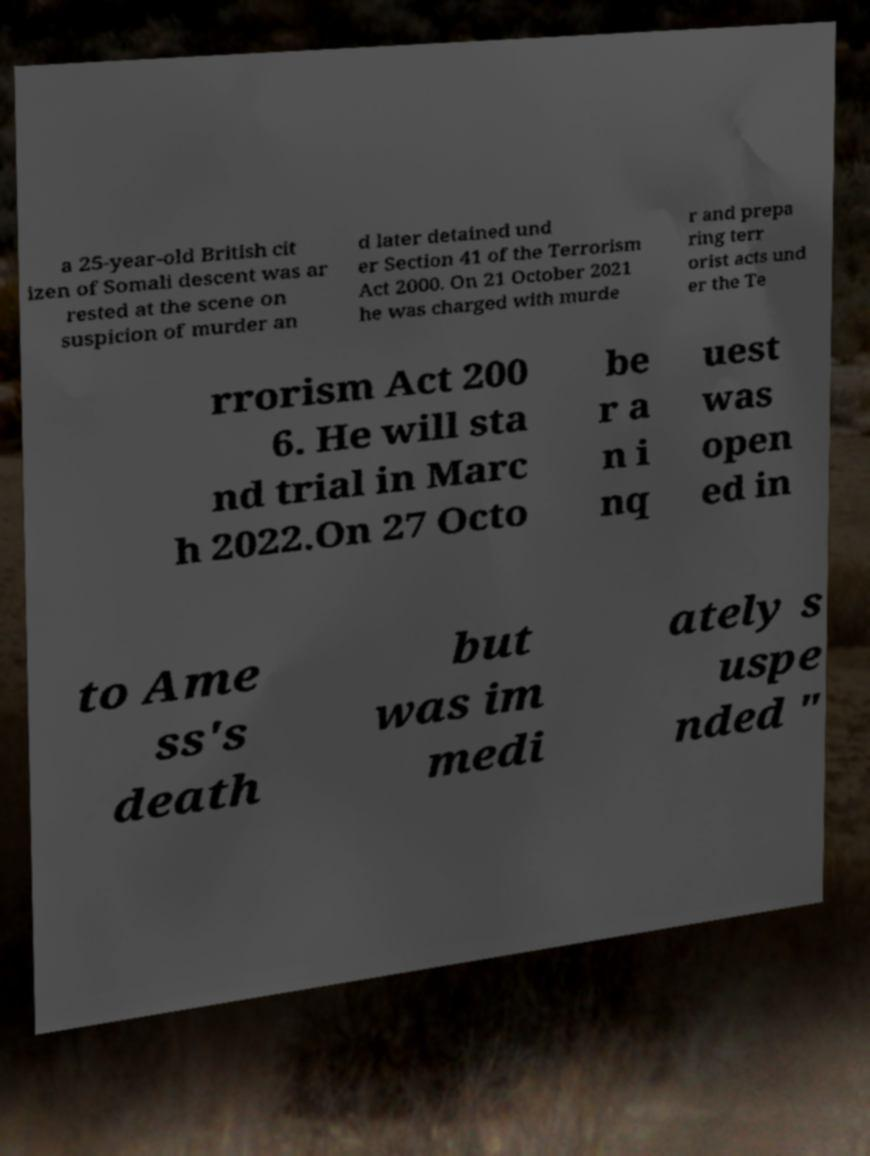Please identify and transcribe the text found in this image. a 25-year-old British cit izen of Somali descent was ar rested at the scene on suspicion of murder an d later detained und er Section 41 of the Terrorism Act 2000. On 21 October 2021 he was charged with murde r and prepa ring terr orist acts und er the Te rrorism Act 200 6. He will sta nd trial in Marc h 2022.On 27 Octo be r a n i nq uest was open ed in to Ame ss's death but was im medi ately s uspe nded " 